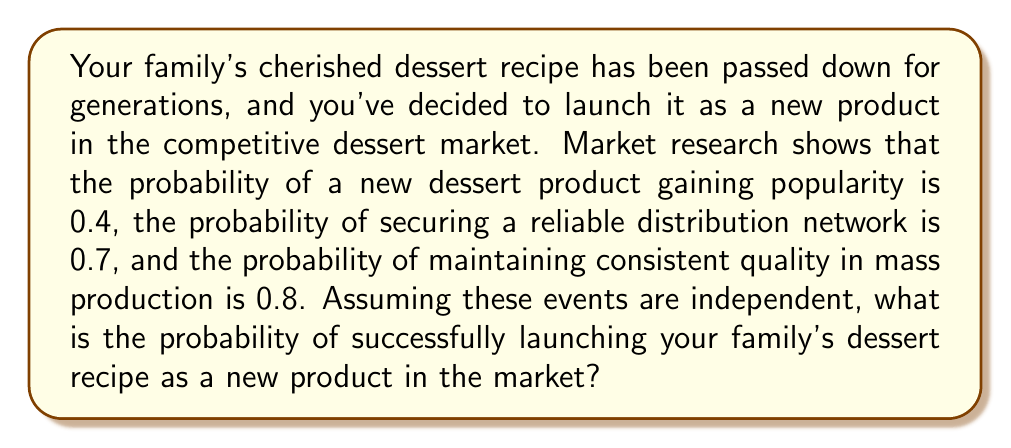Can you solve this math problem? To solve this problem, we need to understand the concept of independent events and how to calculate their joint probability.

1. Given probabilities:
   - Probability of gaining popularity: $P(A) = 0.4$
   - Probability of securing a distribution network: $P(B) = 0.7$
   - Probability of maintaining consistent quality: $P(C) = 0.8$

2. For independent events, the probability of all events occurring simultaneously is the product of their individual probabilities.

3. The probability of successfully launching the product is the probability of all three events occurring together:

   $$P(\text{Success}) = P(A \cap B \cap C) = P(A) \times P(B) \times P(C)$$

4. Substituting the given probabilities:

   $$P(\text{Success}) = 0.4 \times 0.7 \times 0.8$$

5. Calculating the result:

   $$P(\text{Success}) = 0.224$$

Therefore, the probability of successfully launching your family's dessert recipe as a new product in the competitive market is 0.224 or 22.4%.
Answer: 0.224 or 22.4% 